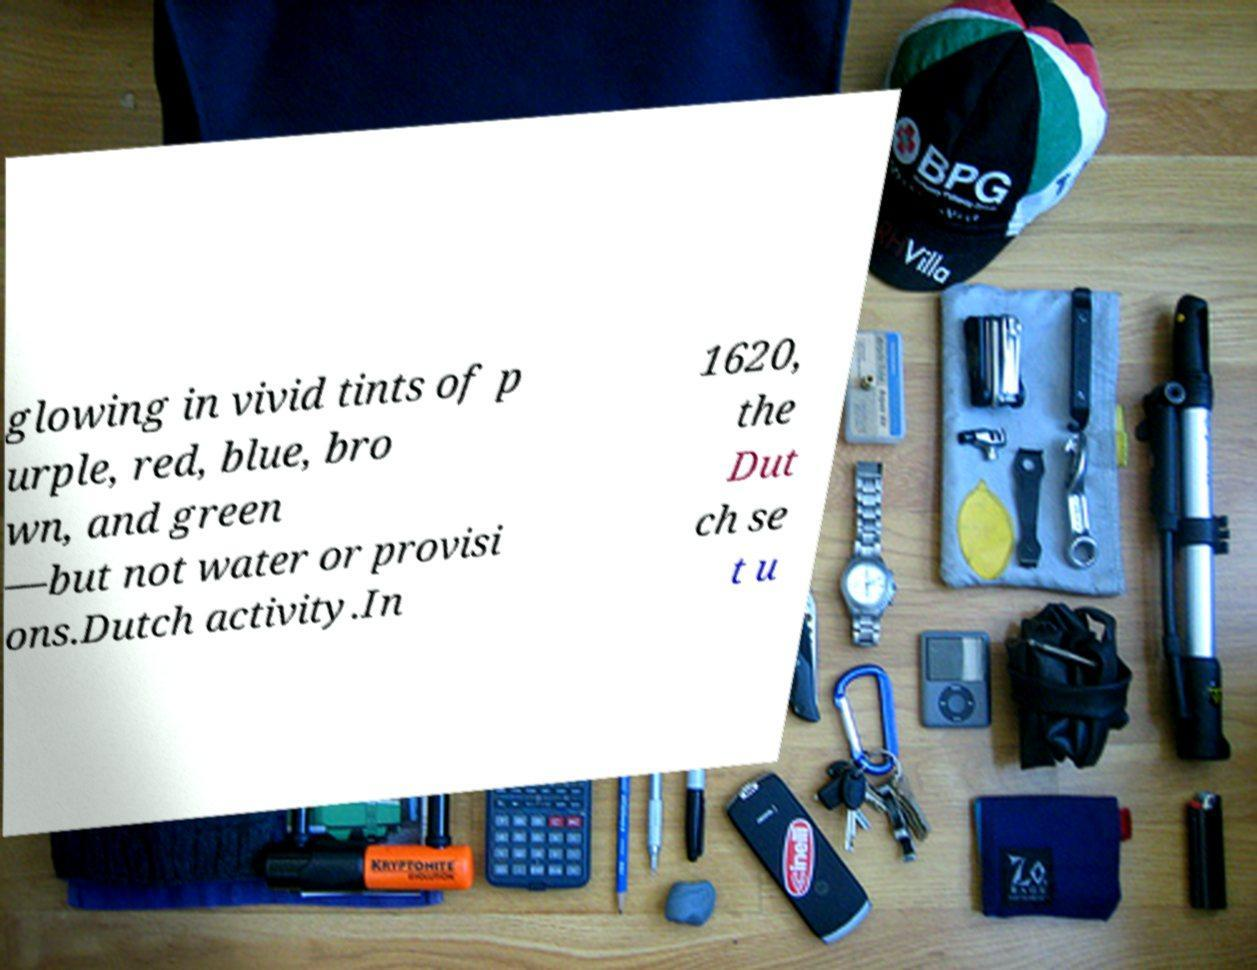Can you read and provide the text displayed in the image?This photo seems to have some interesting text. Can you extract and type it out for me? glowing in vivid tints of p urple, red, blue, bro wn, and green —but not water or provisi ons.Dutch activity.In 1620, the Dut ch se t u 